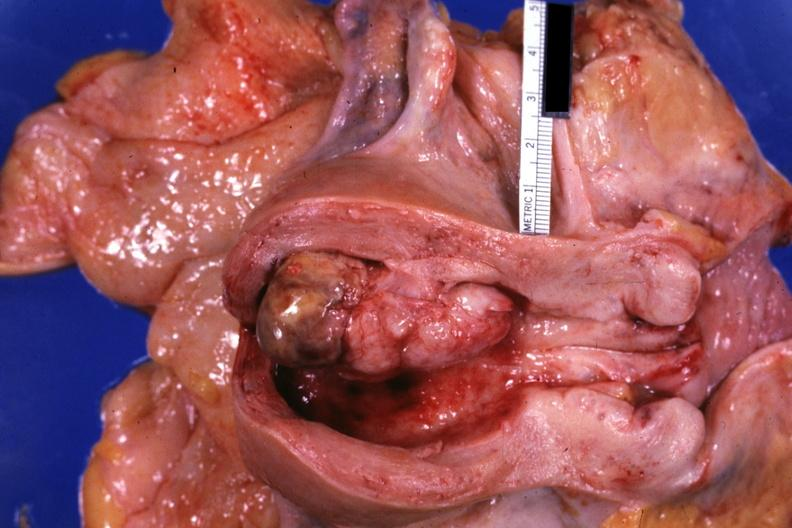what is present?
Answer the question using a single word or phrase. Female reproductive 